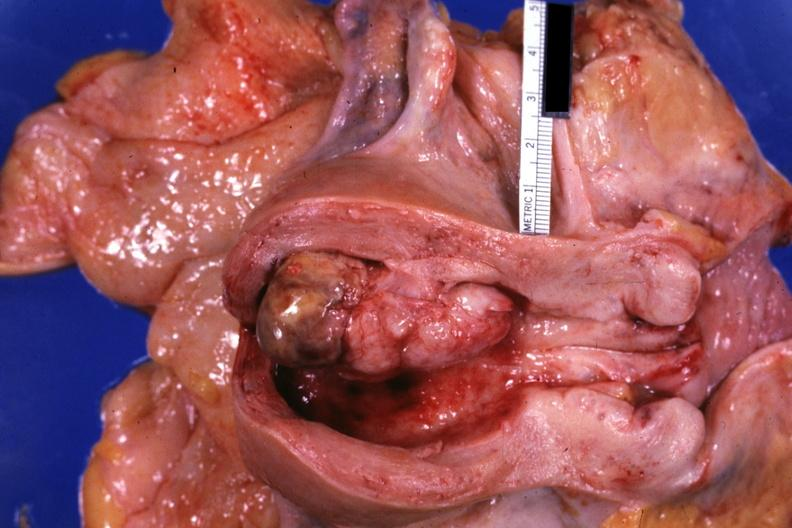what is present?
Answer the question using a single word or phrase. Female reproductive 